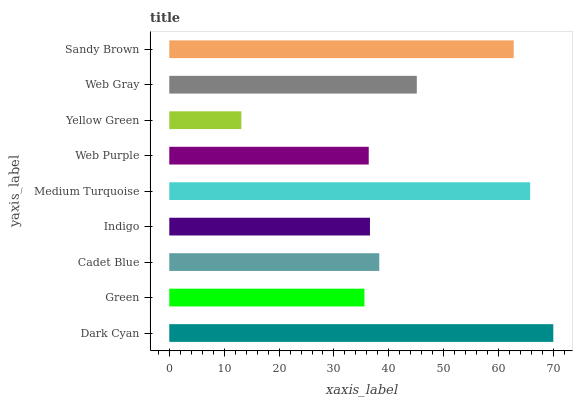Is Yellow Green the minimum?
Answer yes or no. Yes. Is Dark Cyan the maximum?
Answer yes or no. Yes. Is Green the minimum?
Answer yes or no. No. Is Green the maximum?
Answer yes or no. No. Is Dark Cyan greater than Green?
Answer yes or no. Yes. Is Green less than Dark Cyan?
Answer yes or no. Yes. Is Green greater than Dark Cyan?
Answer yes or no. No. Is Dark Cyan less than Green?
Answer yes or no. No. Is Cadet Blue the high median?
Answer yes or no. Yes. Is Cadet Blue the low median?
Answer yes or no. Yes. Is Sandy Brown the high median?
Answer yes or no. No. Is Medium Turquoise the low median?
Answer yes or no. No. 